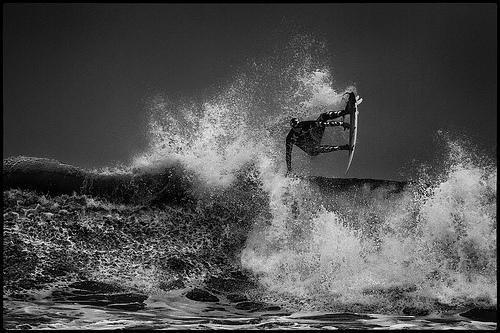How many people are there?
Give a very brief answer. 1. 